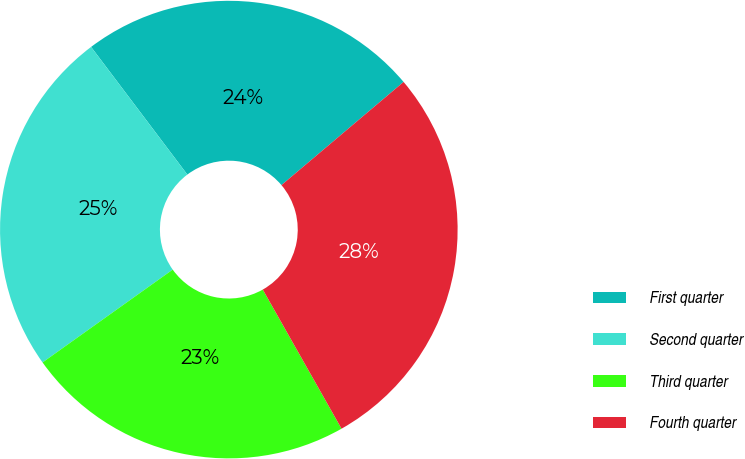<chart> <loc_0><loc_0><loc_500><loc_500><pie_chart><fcel>First quarter<fcel>Second quarter<fcel>Third quarter<fcel>Fourth quarter<nl><fcel>24.12%<fcel>24.58%<fcel>23.34%<fcel>27.97%<nl></chart> 